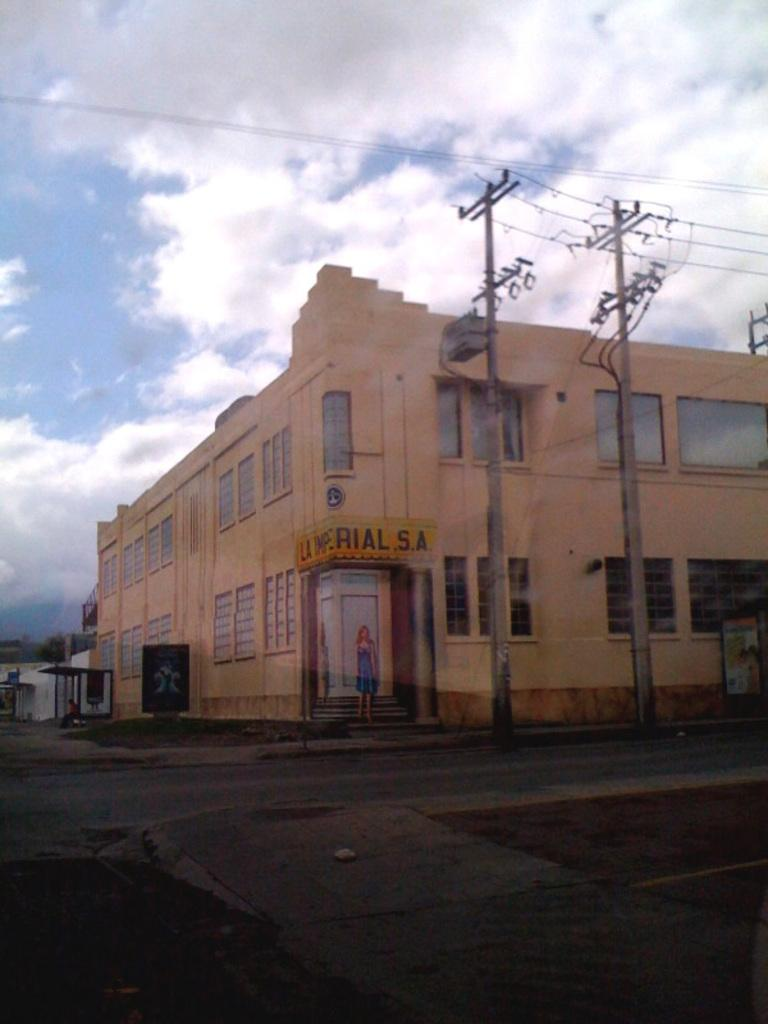What type of structure is visible in the image? There is a building in the image. What is the surrounding area like around the building? There is a plain road around the building. Are there any additional features on the right side of the image? Yes, there are two current poles on the right side of the image. Can you see anyone sleeping near the building in the image? There is no indication of anyone sleeping in the image; it only shows the building, a plain road, and two current poles. Is there a hose connected to the building in the image? There is no hose visible in the image. 